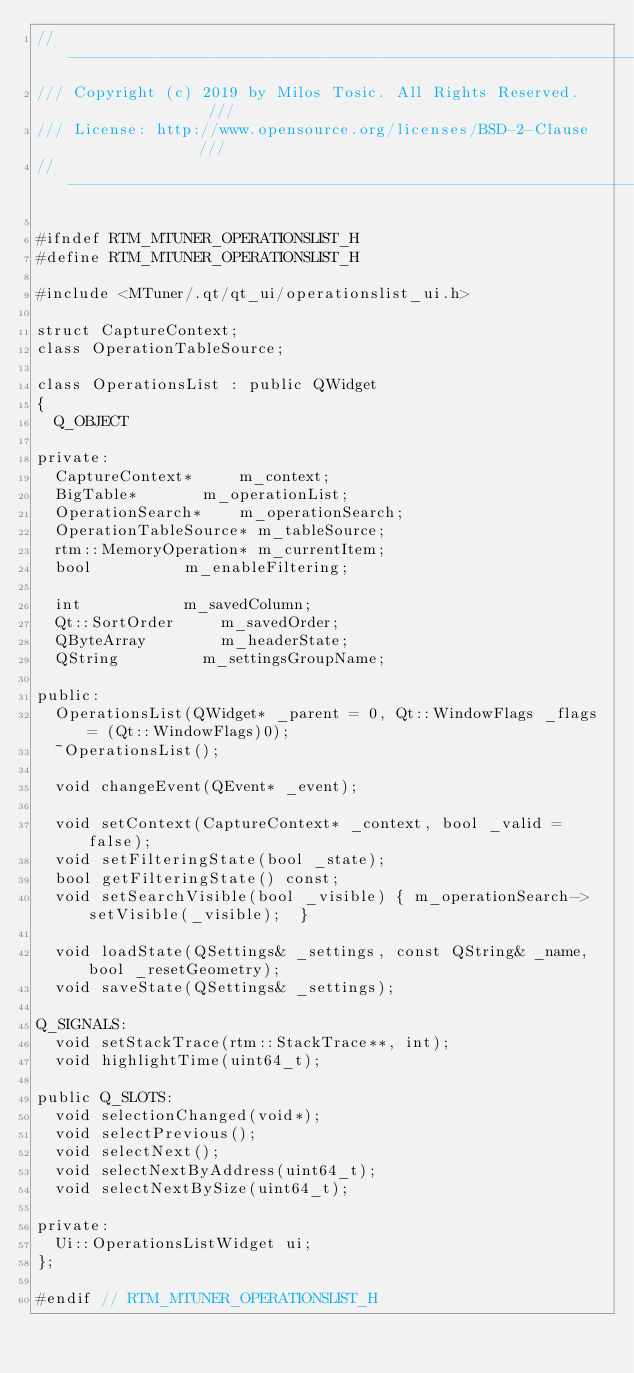Convert code to text. <code><loc_0><loc_0><loc_500><loc_500><_C_>//--------------------------------------------------------------------------//
/// Copyright (c) 2019 by Milos Tosic. All Rights Reserved.                ///
/// License: http://www.opensource.org/licenses/BSD-2-Clause               ///
//--------------------------------------------------------------------------//

#ifndef RTM_MTUNER_OPERATIONSLIST_H
#define RTM_MTUNER_OPERATIONSLIST_H

#include <MTuner/.qt/qt_ui/operationslist_ui.h>

struct CaptureContext;
class OperationTableSource;

class OperationsList : public QWidget
{
	Q_OBJECT

private:
	CaptureContext*			m_context;
	BigTable*				m_operationList;
	OperationSearch*		m_operationSearch;
	OperationTableSource*	m_tableSource;
	rtm::MemoryOperation*	m_currentItem;
	bool					m_enableFiltering;

	int						m_savedColumn;
	Qt::SortOrder			m_savedOrder;
	QByteArray				m_headerState;
	QString					m_settingsGroupName;

public:
	OperationsList(QWidget* _parent = 0, Qt::WindowFlags _flags = (Qt::WindowFlags)0);
	~OperationsList();

	void changeEvent(QEvent* _event);

	void setContext(CaptureContext* _context, bool _valid = false);
	void setFilteringState(bool _state);
	bool getFilteringState() const;
	void setSearchVisible(bool _visible) { m_operationSearch->setVisible(_visible);  }

	void loadState(QSettings& _settings, const QString& _name, bool _resetGeometry);
	void saveState(QSettings& _settings);

Q_SIGNALS:
	void setStackTrace(rtm::StackTrace**, int);
	void highlightTime(uint64_t);

public Q_SLOTS:
	void selectionChanged(void*);
	void selectPrevious();
	void selectNext();
	void selectNextByAddress(uint64_t);
	void selectNextBySize(uint64_t);

private:
	Ui::OperationsListWidget ui;
};

#endif // RTM_MTUNER_OPERATIONSLIST_H
</code> 